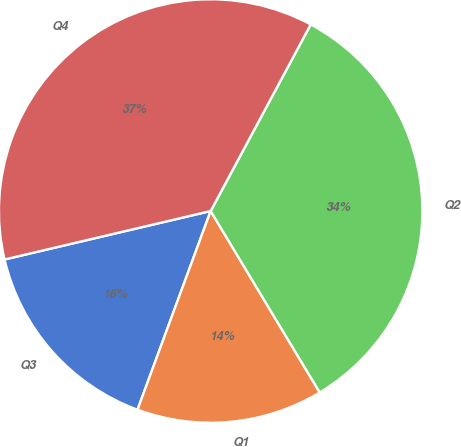Convert chart to OTSL. <chart><loc_0><loc_0><loc_500><loc_500><pie_chart><fcel>Q3<fcel>Q1<fcel>Q2<fcel>Q4<nl><fcel>15.71%<fcel>14.23%<fcel>33.55%<fcel>36.51%<nl></chart> 